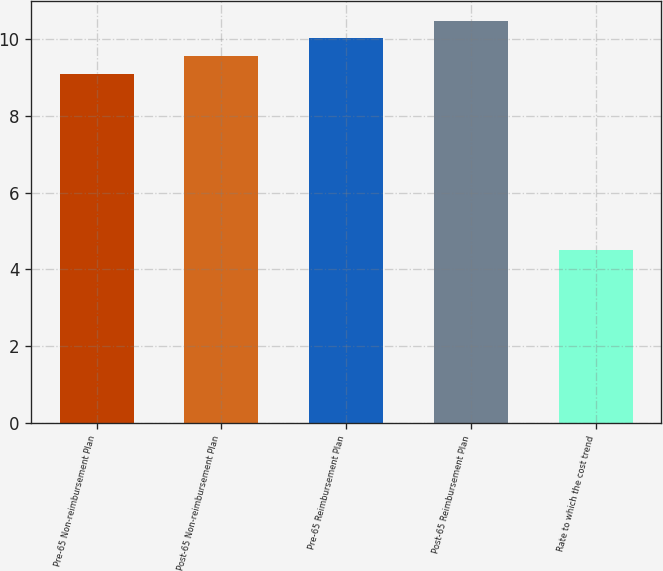Convert chart. <chart><loc_0><loc_0><loc_500><loc_500><bar_chart><fcel>Pre-65 Non-reimbursement Plan<fcel>Post-65 Non-reimbursement Plan<fcel>Pre-65 Reimbursement Plan<fcel>Post-65 Reimbursement Plan<fcel>Rate to which the cost trend<nl><fcel>9.1<fcel>9.56<fcel>10.02<fcel>10.48<fcel>4.5<nl></chart> 